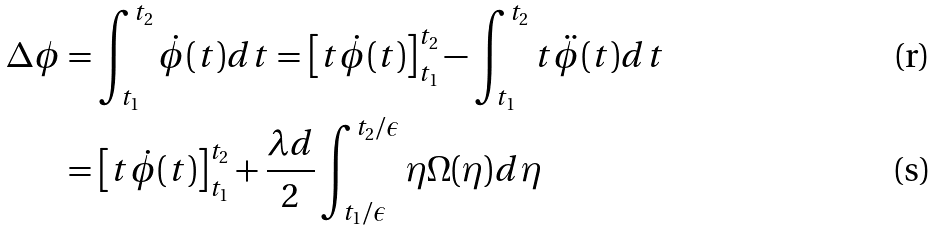Convert formula to latex. <formula><loc_0><loc_0><loc_500><loc_500>\Delta \phi & = \int _ { t _ { 1 } } ^ { t _ { 2 } } \dot { \phi } ( t ) d t = \left [ t \dot { \phi } ( t ) \right ] _ { t _ { 1 } } ^ { t _ { 2 } } - \int _ { t _ { 1 } } ^ { t _ { 2 } } t \ddot { \phi } ( t ) d t \\ & = \left [ t \dot { \phi } ( t ) \right ] _ { t _ { 1 } } ^ { t _ { 2 } } + \frac { \lambda d } { 2 } \int _ { t _ { 1 } / \epsilon } ^ { t _ { 2 } / \epsilon } \eta \Omega ( \eta ) d \eta</formula> 